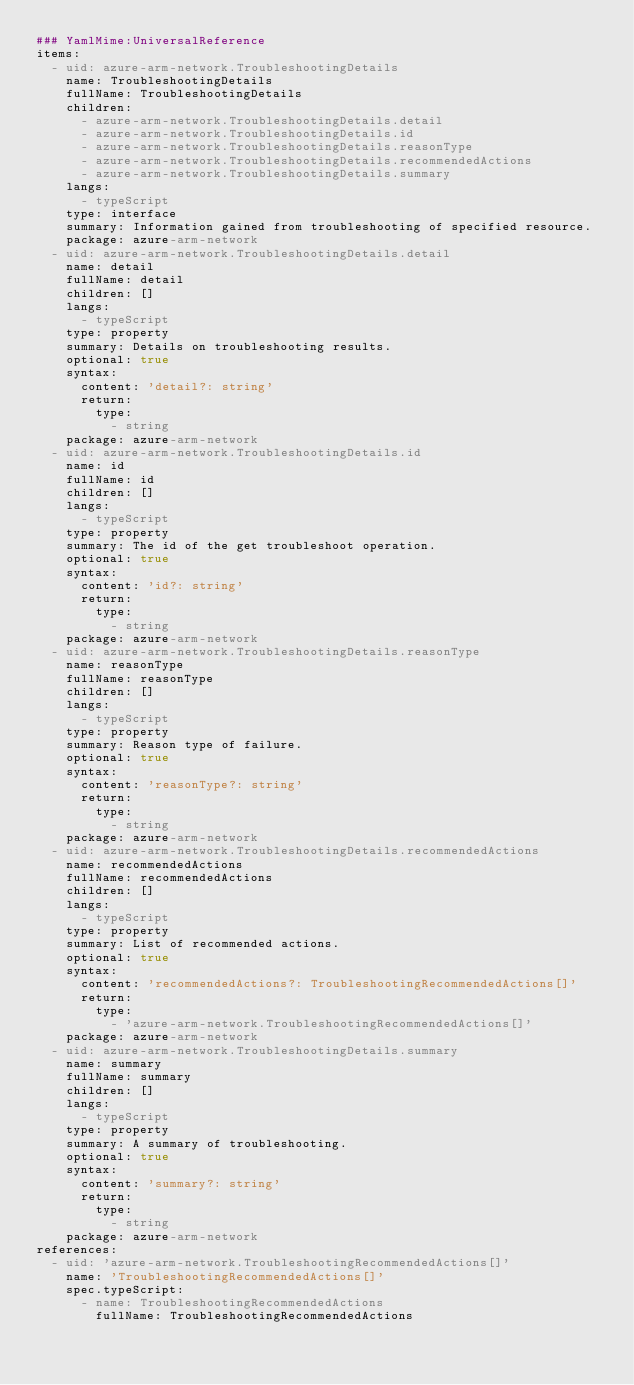Convert code to text. <code><loc_0><loc_0><loc_500><loc_500><_YAML_>### YamlMime:UniversalReference
items:
  - uid: azure-arm-network.TroubleshootingDetails
    name: TroubleshootingDetails
    fullName: TroubleshootingDetails
    children:
      - azure-arm-network.TroubleshootingDetails.detail
      - azure-arm-network.TroubleshootingDetails.id
      - azure-arm-network.TroubleshootingDetails.reasonType
      - azure-arm-network.TroubleshootingDetails.recommendedActions
      - azure-arm-network.TroubleshootingDetails.summary
    langs:
      - typeScript
    type: interface
    summary: Information gained from troubleshooting of specified resource.
    package: azure-arm-network
  - uid: azure-arm-network.TroubleshootingDetails.detail
    name: detail
    fullName: detail
    children: []
    langs:
      - typeScript
    type: property
    summary: Details on troubleshooting results.
    optional: true
    syntax:
      content: 'detail?: string'
      return:
        type:
          - string
    package: azure-arm-network
  - uid: azure-arm-network.TroubleshootingDetails.id
    name: id
    fullName: id
    children: []
    langs:
      - typeScript
    type: property
    summary: The id of the get troubleshoot operation.
    optional: true
    syntax:
      content: 'id?: string'
      return:
        type:
          - string
    package: azure-arm-network
  - uid: azure-arm-network.TroubleshootingDetails.reasonType
    name: reasonType
    fullName: reasonType
    children: []
    langs:
      - typeScript
    type: property
    summary: Reason type of failure.
    optional: true
    syntax:
      content: 'reasonType?: string'
      return:
        type:
          - string
    package: azure-arm-network
  - uid: azure-arm-network.TroubleshootingDetails.recommendedActions
    name: recommendedActions
    fullName: recommendedActions
    children: []
    langs:
      - typeScript
    type: property
    summary: List of recommended actions.
    optional: true
    syntax:
      content: 'recommendedActions?: TroubleshootingRecommendedActions[]'
      return:
        type:
          - 'azure-arm-network.TroubleshootingRecommendedActions[]'
    package: azure-arm-network
  - uid: azure-arm-network.TroubleshootingDetails.summary
    name: summary
    fullName: summary
    children: []
    langs:
      - typeScript
    type: property
    summary: A summary of troubleshooting.
    optional: true
    syntax:
      content: 'summary?: string'
      return:
        type:
          - string
    package: azure-arm-network
references:
  - uid: 'azure-arm-network.TroubleshootingRecommendedActions[]'
    name: 'TroubleshootingRecommendedActions[]'
    spec.typeScript:
      - name: TroubleshootingRecommendedActions
        fullName: TroubleshootingRecommendedActions</code> 